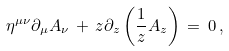Convert formula to latex. <formula><loc_0><loc_0><loc_500><loc_500>\eta ^ { \mu \nu } \partial _ { \mu } A _ { \nu } \, + \, z \partial _ { z } \left ( \frac { 1 } { z } A _ { z } \right ) \, = \, 0 \, ,</formula> 